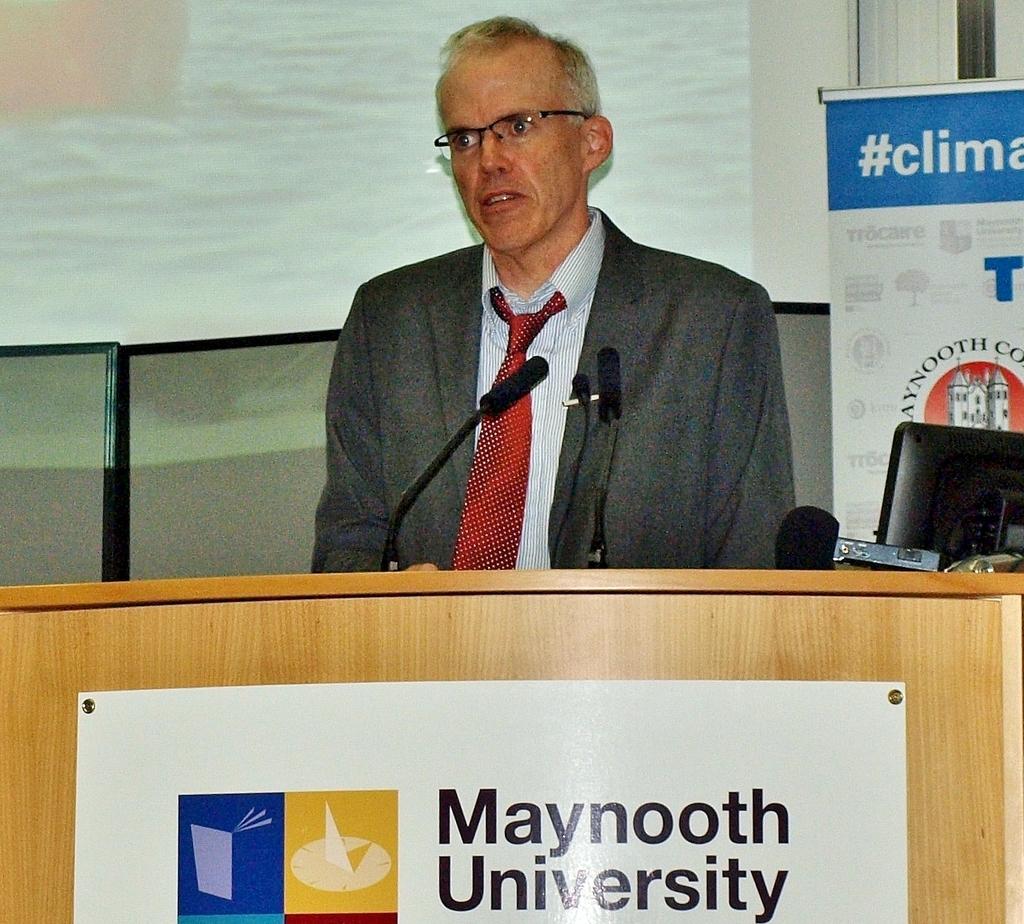What university is on the poster?
Offer a terse response. Maynooth. 